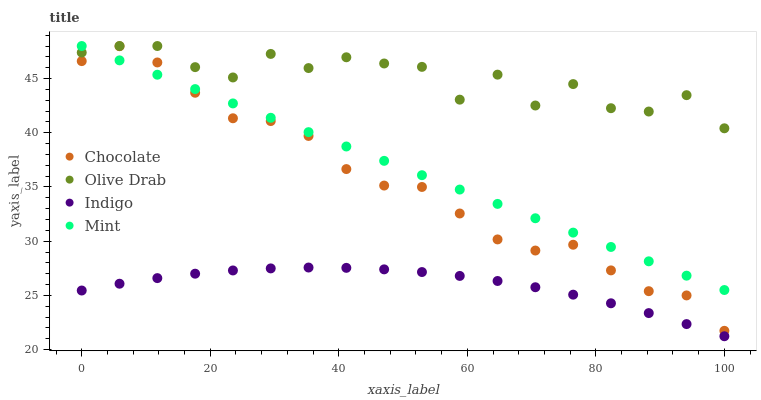Does Indigo have the minimum area under the curve?
Answer yes or no. Yes. Does Olive Drab have the maximum area under the curve?
Answer yes or no. Yes. Does Olive Drab have the minimum area under the curve?
Answer yes or no. No. Does Indigo have the maximum area under the curve?
Answer yes or no. No. Is Mint the smoothest?
Answer yes or no. Yes. Is Olive Drab the roughest?
Answer yes or no. Yes. Is Indigo the smoothest?
Answer yes or no. No. Is Indigo the roughest?
Answer yes or no. No. Does Indigo have the lowest value?
Answer yes or no. Yes. Does Olive Drab have the lowest value?
Answer yes or no. No. Does Olive Drab have the highest value?
Answer yes or no. Yes. Does Indigo have the highest value?
Answer yes or no. No. Is Chocolate less than Olive Drab?
Answer yes or no. Yes. Is Olive Drab greater than Indigo?
Answer yes or no. Yes. Does Olive Drab intersect Mint?
Answer yes or no. Yes. Is Olive Drab less than Mint?
Answer yes or no. No. Is Olive Drab greater than Mint?
Answer yes or no. No. Does Chocolate intersect Olive Drab?
Answer yes or no. No. 